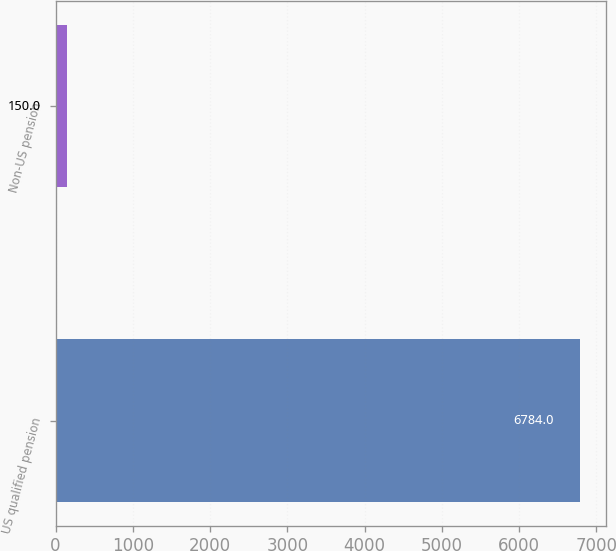<chart> <loc_0><loc_0><loc_500><loc_500><bar_chart><fcel>US qualified pension<fcel>Non-US pension<nl><fcel>6784<fcel>150<nl></chart> 